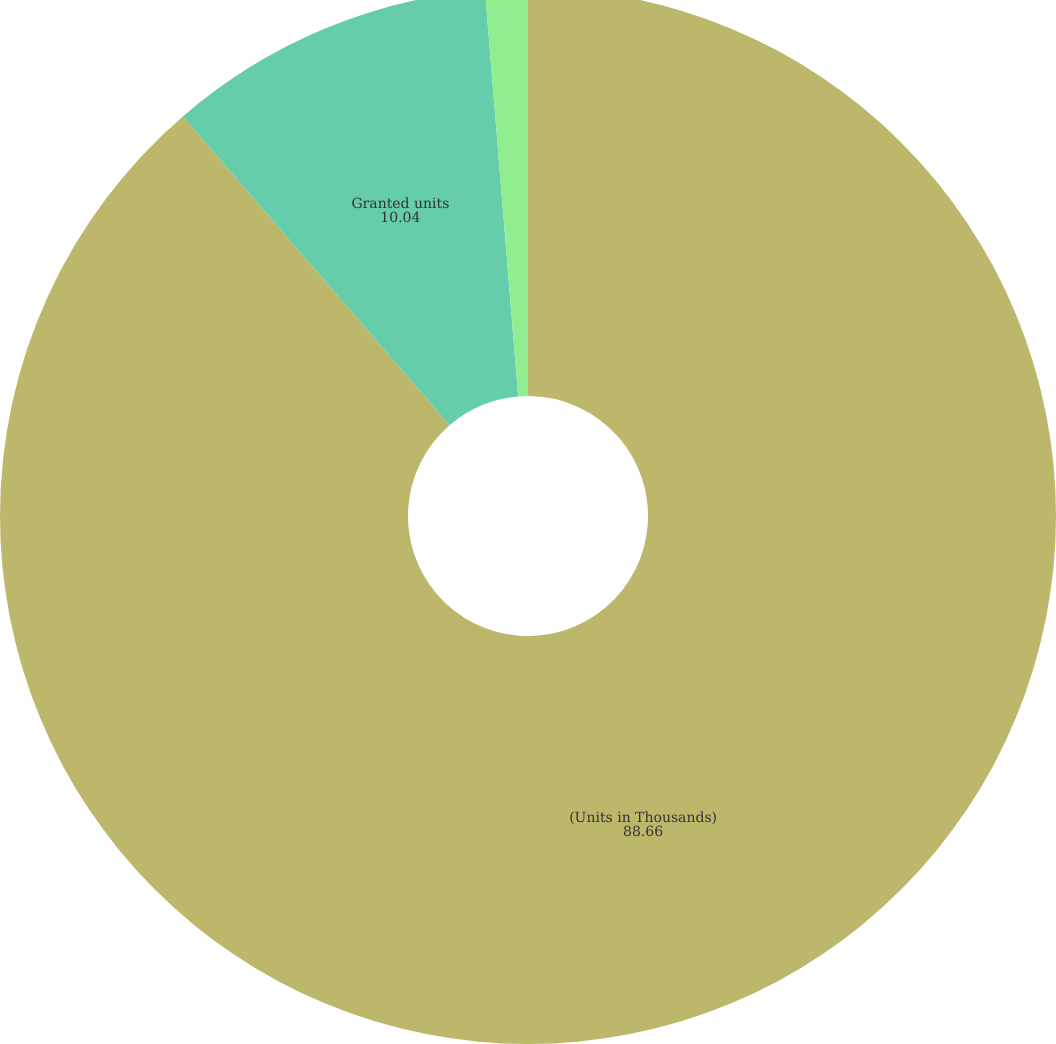Convert chart. <chart><loc_0><loc_0><loc_500><loc_500><pie_chart><fcel>(Units in Thousands)<fcel>Granted units<fcel>Grant date fair value<nl><fcel>88.66%<fcel>10.04%<fcel>1.3%<nl></chart> 